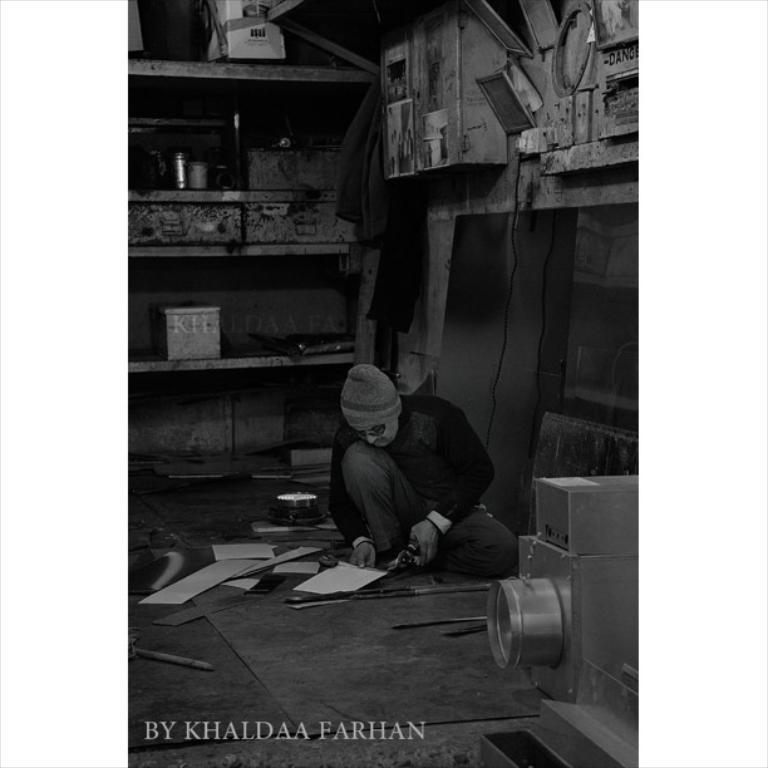In one or two sentences, can you explain what this image depicts? In this image I can see a man is sitting in the centre and I can see he is holding few things. On the top side and in the background I can see number of things. On the bottom left side of this image I can see a watermark and I can see this image is black and white in colour. 